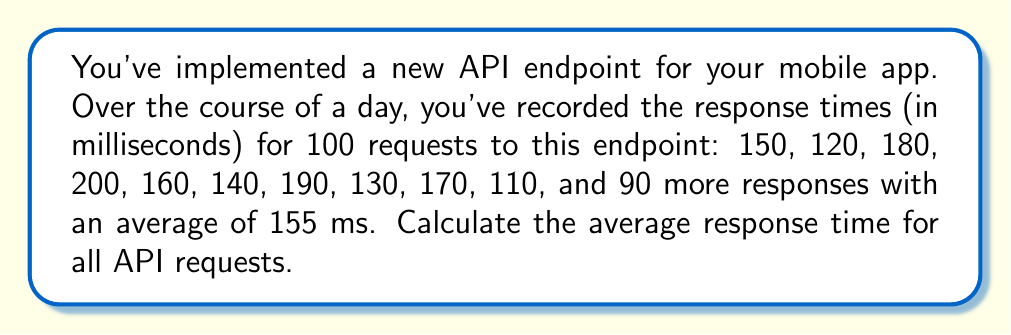Teach me how to tackle this problem. Let's approach this step-by-step:

1) First, let's sum up the 10 explicitly given response times:
   $$150 + 120 + 180 + 200 + 160 + 140 + 190 + 130 + 170 + 110 = 1550$$

2) Now, we're told there are 90 more responses with an average of 155 ms. The sum of these can be calculated as:
   $$90 \times 155 = 13950$$

3) Let's add these two sums together to get the total sum of all response times:
   $$1550 + 13950 = 15500$$

4) We know there were 100 requests in total (10 explicit + 90 others).

5) To calculate the average, we divide the total sum by the number of requests:
   $$\text{Average} = \frac{\text{Sum of all response times}}{\text{Number of requests}} = \frac{15500}{100} = 155$$

Therefore, the average response time for all API requests is 155 ms.
Answer: 155 ms 